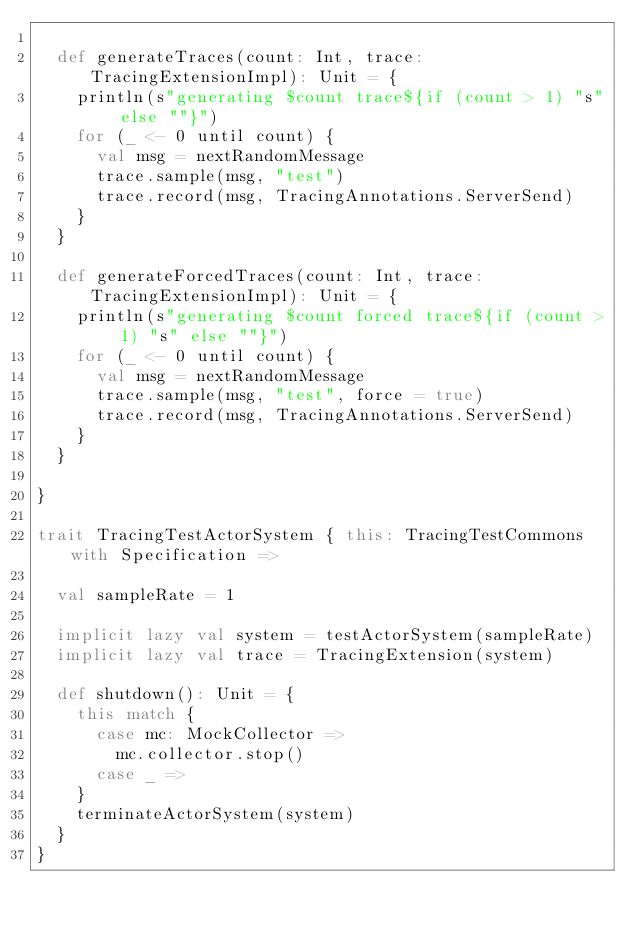Convert code to text. <code><loc_0><loc_0><loc_500><loc_500><_Scala_>
  def generateTraces(count: Int, trace: TracingExtensionImpl): Unit = {
    println(s"generating $count trace${if (count > 1) "s" else ""}")
    for (_ <- 0 until count) {
      val msg = nextRandomMessage
      trace.sample(msg, "test")
      trace.record(msg, TracingAnnotations.ServerSend)
    }
  }

  def generateForcedTraces(count: Int, trace: TracingExtensionImpl): Unit = {
    println(s"generating $count forced trace${if (count > 1) "s" else ""}")
    for (_ <- 0 until count) {
      val msg = nextRandomMessage
      trace.sample(msg, "test", force = true)
      trace.record(msg, TracingAnnotations.ServerSend)
    }
  }

}

trait TracingTestActorSystem { this: TracingTestCommons with Specification =>

  val sampleRate = 1

  implicit lazy val system = testActorSystem(sampleRate)
  implicit lazy val trace = TracingExtension(system)

  def shutdown(): Unit = {
    this match {
      case mc: MockCollector =>
        mc.collector.stop()
      case _ =>
    }
    terminateActorSystem(system)
  }
}</code> 